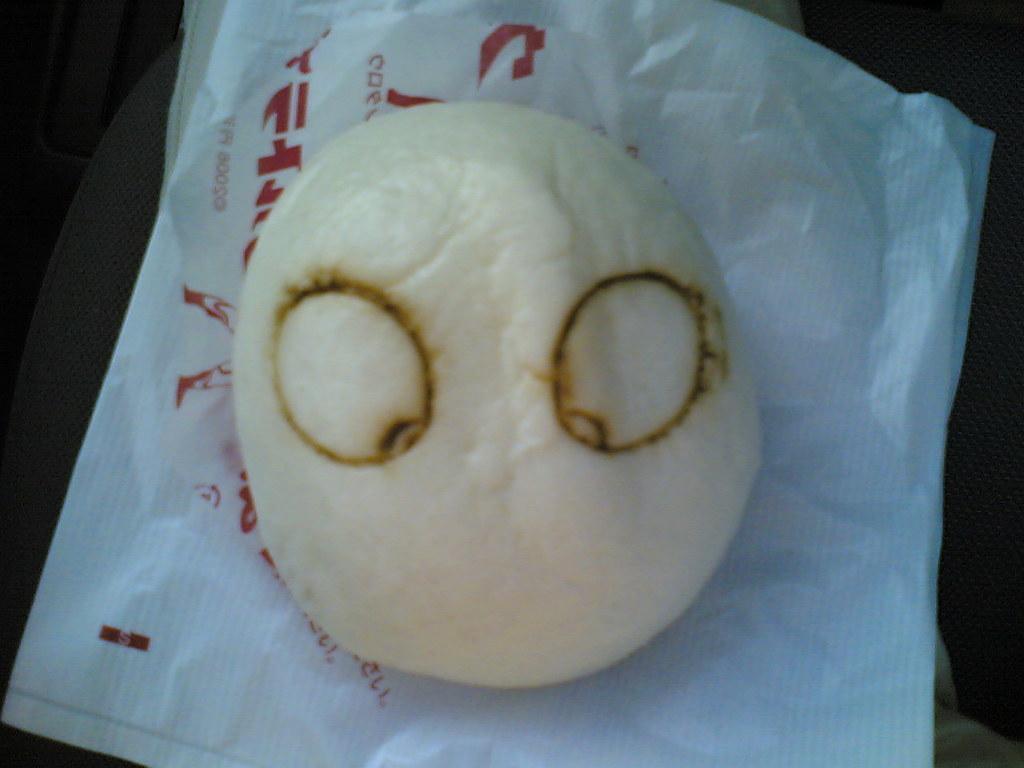How would you summarize this image in a sentence or two? In this image, we can see an object on paper. 